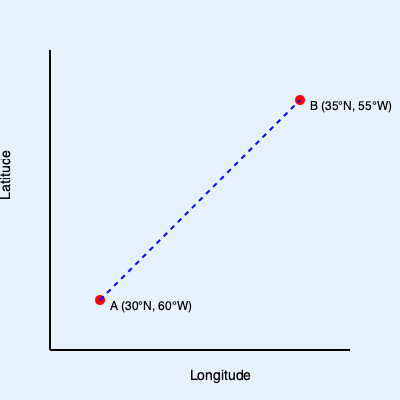Using the nautical chart provided, calculate the approximate distance in nautical miles between point A (30°N, 60°W) and point B (35°N, 55°W). Assume 1 degree of latitude equals 60 nautical miles. To calculate the distance between two points on a nautical chart, we can use the following steps:

1. Calculate the difference in latitude:
   $\Delta lat = 35°N - 30°N = 5°$

2. Calculate the difference in longitude:
   $\Delta lon = 60°W - 55°W = 5°$

3. Convert latitude difference to nautical miles:
   $\Delta lat_{nm} = 5° \times 60 \frac{nm}{degree} = 300$ nm

4. Calculate the average latitude:
   $avg_{lat} = \frac{30°N + 35°N}{2} = 32.5°N$

5. Convert longitude difference to nautical miles:
   $\Delta lon_{nm} = 5° \times 60 \frac{nm}{degree} \times \cos(32.5°) \approx 252.8$ nm

6. Use the Pythagorean theorem to calculate the distance:
   $distance = \sqrt{(\Delta lat_{nm})^2 + (\Delta lon_{nm})^2}$
   $distance = \sqrt{300^2 + 252.8^2} \approx 392.3$ nm

Therefore, the approximate distance between point A and point B is 392.3 nautical miles.
Answer: 392.3 nautical miles 